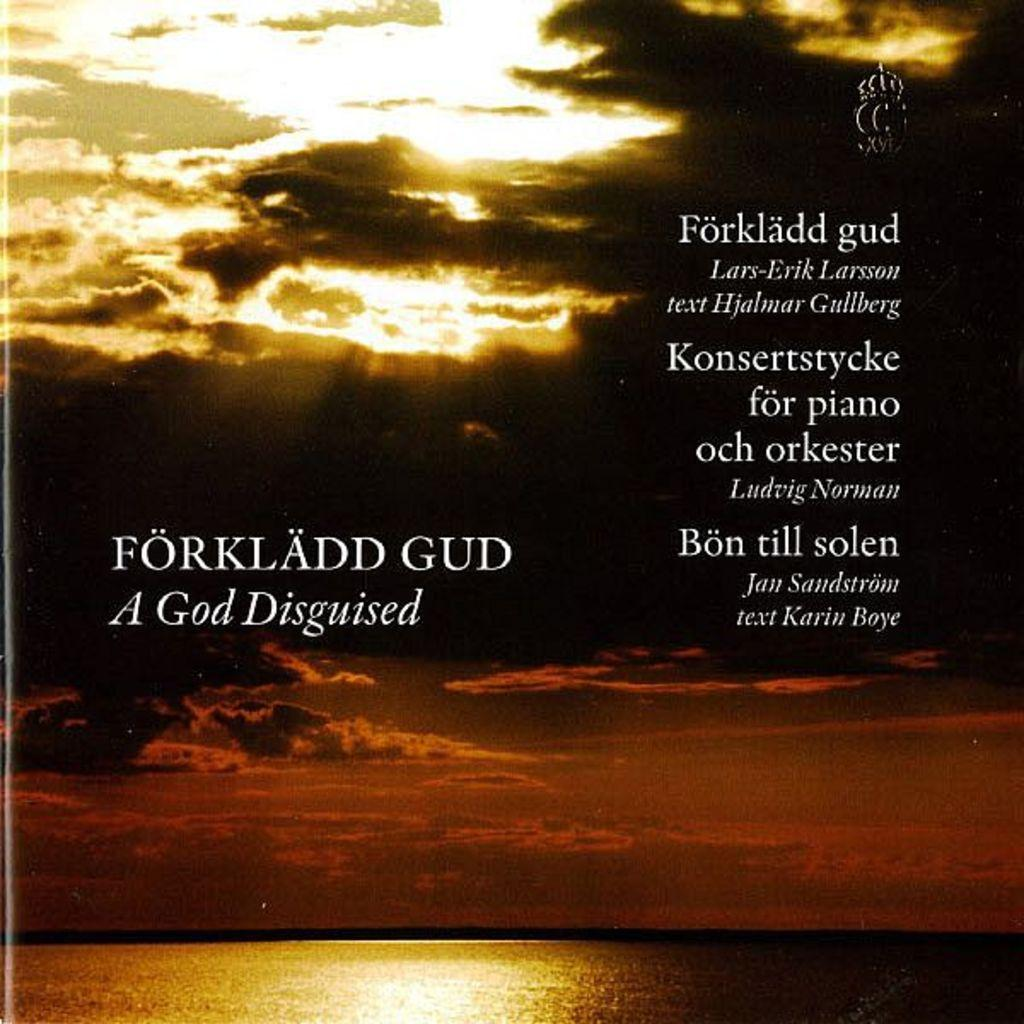<image>
Give a short and clear explanation of the subsequent image. A picture of the ocean with the caption A God Disguised. 